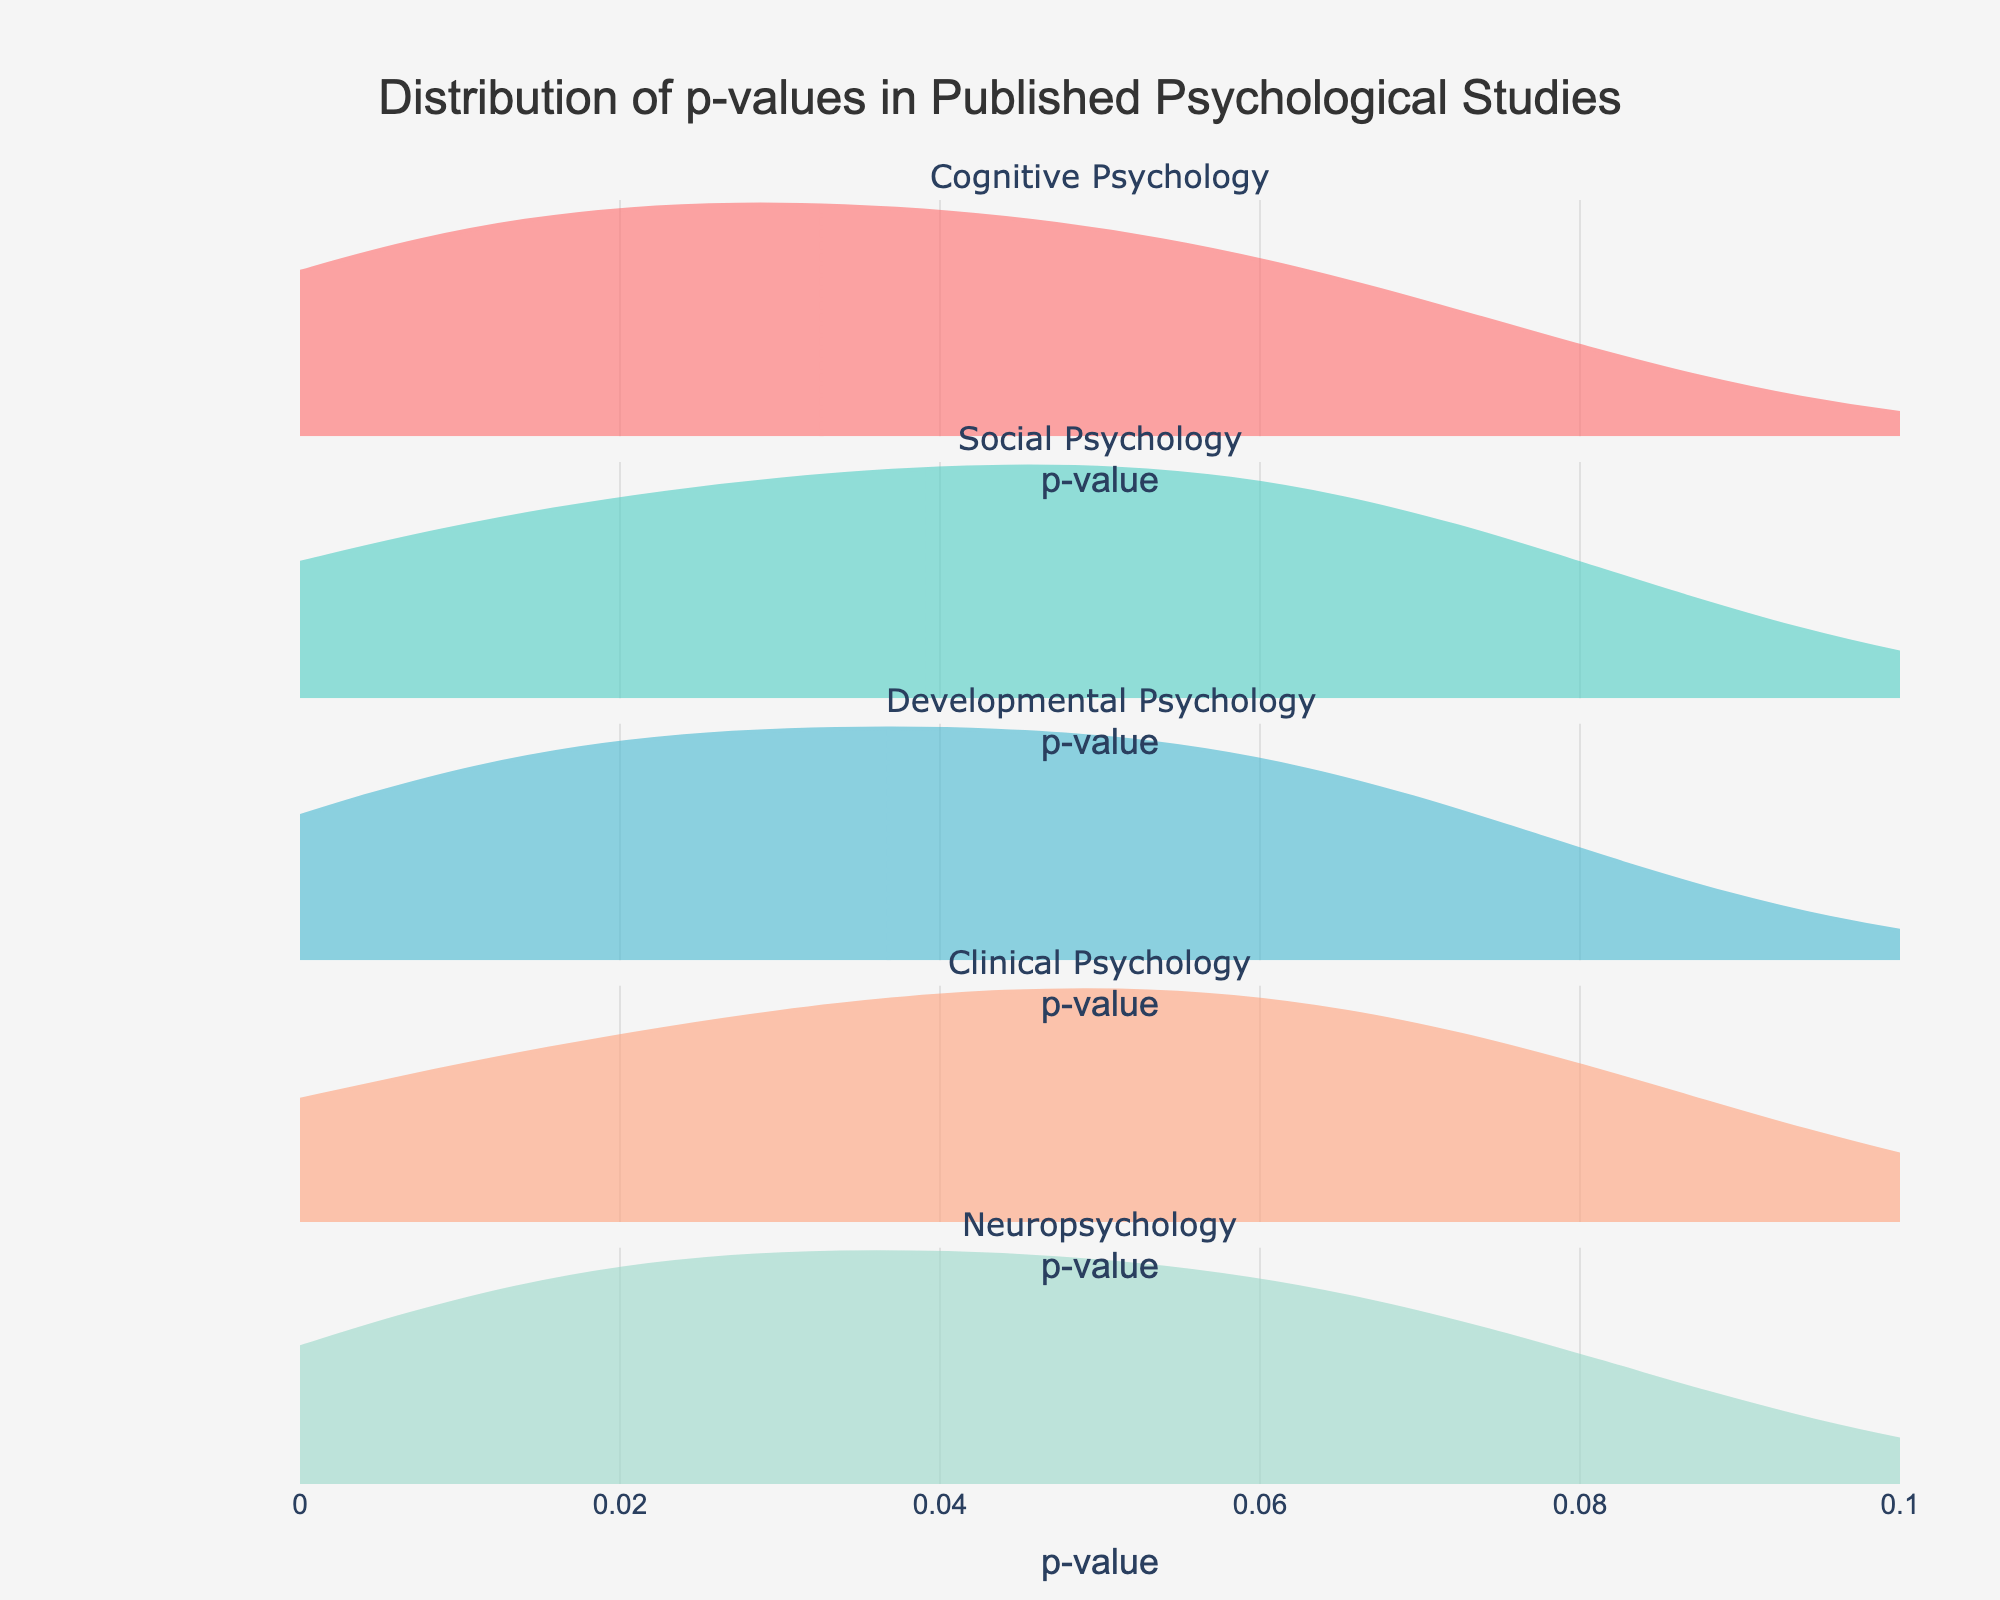What is the title of the figure? The title is clearly stated at the top of the figure. It reads, "Distribution of p-values in Published Psychological Studies."
Answer: Distribution of p-values in Published Psychological Studies What is the range of the p-value axis? By examining the x-axis of the plot, the range is from 0 to 0.1.
Answer: 0 to 0.1 Which subfield has the most evenly spread distribution of p-values? By comparing the density plots of each subfield, Cognitive Psychology shows the most evenly spread distribution as it does not have peaks or clusters.
Answer: Cognitive Psychology Are there more very significant p-values (closer to 0) in Social Psychology compared to Clinical Psychology? Observing the density plots, Social Psychology has more observations in the very low p-value range (close to 0) compared to Clinical Psychology, which has fewer data points in that range.
Answer: Yes Which subfield shows the least variability in p-values? Least variability appears in Social Psychology as its density plot shows the least spread around the central values.
Answer: Social Psychology Which subfield has the highest concentration of p-values near 0.05? By looking at the distributions, Cognitive Psychology shows a higher concentration near 0.05 compared to other subfields.
Answer: Cognitive Psychology Are the p-values in Developmental Psychology more spread out or clustered compared to Neuropsychology? Comparing the density plots, the p-values in Developmental Psychology are more spread out while Neuropsychology shows more clustering towards lower p-values.
Answer: More spread out Does any subfield show a prominent peak around the p-value of 0.02? The density plot for Social Psychology shows a prominent peak around the p-value of 0.02.
Answer: Social Psychology How many unique subfields are shown in the figure? There are five subplot titles, each representing a unique subfield.
Answer: Five 